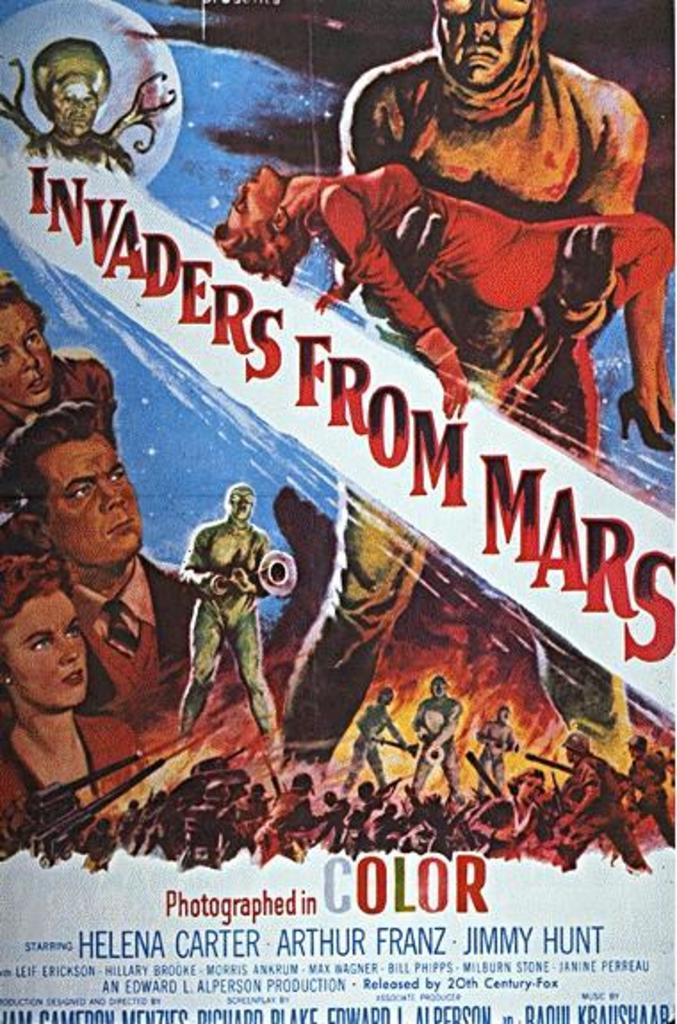Provide a one-sentence caption for the provided image. A movie poster advertises the film "Invaders From Mars.". 